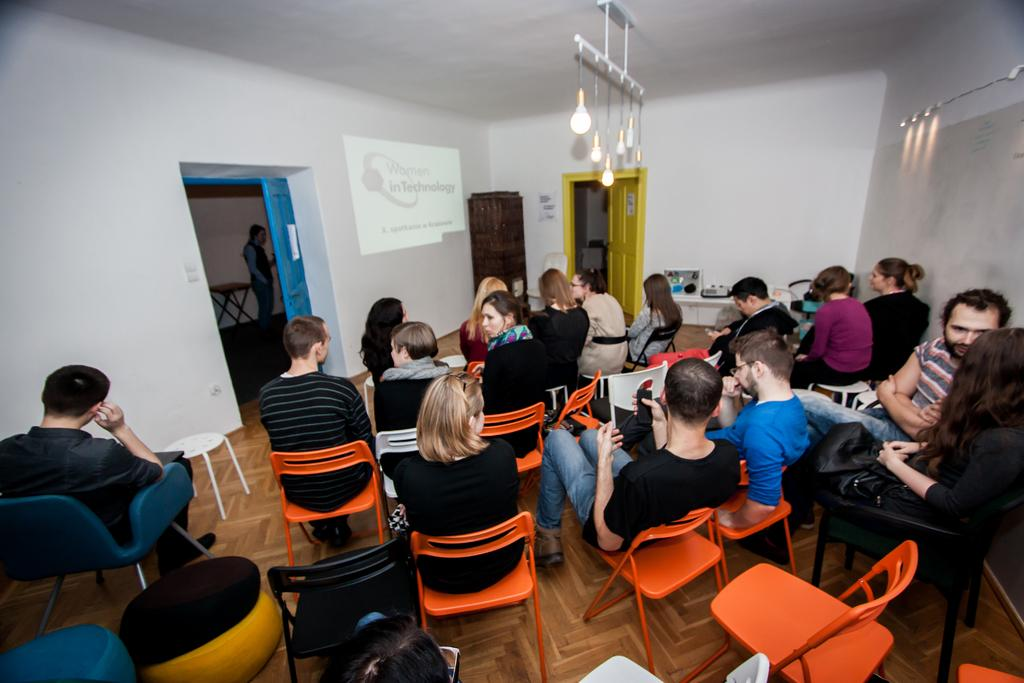How many people can be seen sitting in the image? There are many persons sitting on chairs in the image. What can be seen at the top of the image? There are lights visible at the top of the image. What objects are in the background of the image? There is a door, a table, and a person in the background of the image. What type of structure is visible in the background of the image? There is a wall in the background of the image. What type of hose is being used by the person in the image? There is no hose present in the image. Can you tell me the color of the kitty sitting on the table in the image? There is no kitty present in the image. 